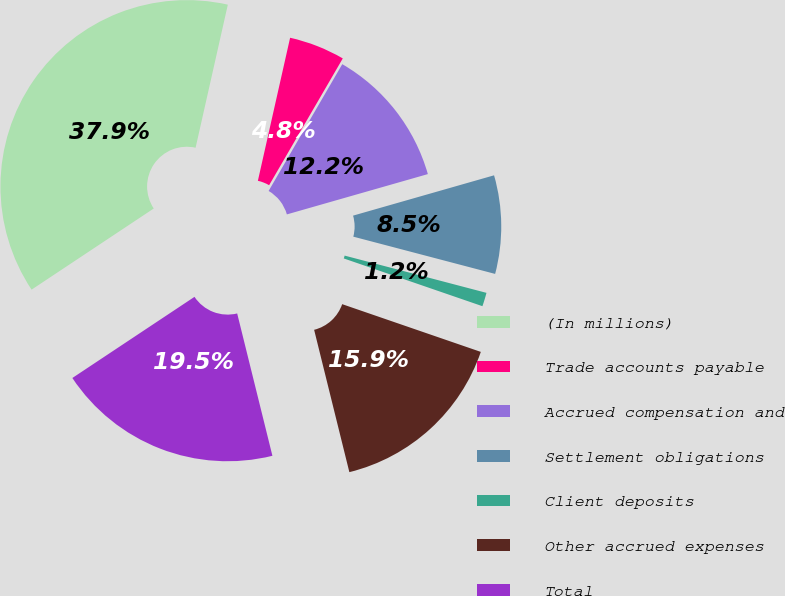Convert chart. <chart><loc_0><loc_0><loc_500><loc_500><pie_chart><fcel>(In millions)<fcel>Trade accounts payable<fcel>Accrued compensation and<fcel>Settlement obligations<fcel>Client deposits<fcel>Other accrued expenses<fcel>Total<nl><fcel>37.86%<fcel>4.85%<fcel>12.19%<fcel>8.52%<fcel>1.19%<fcel>15.86%<fcel>19.53%<nl></chart> 